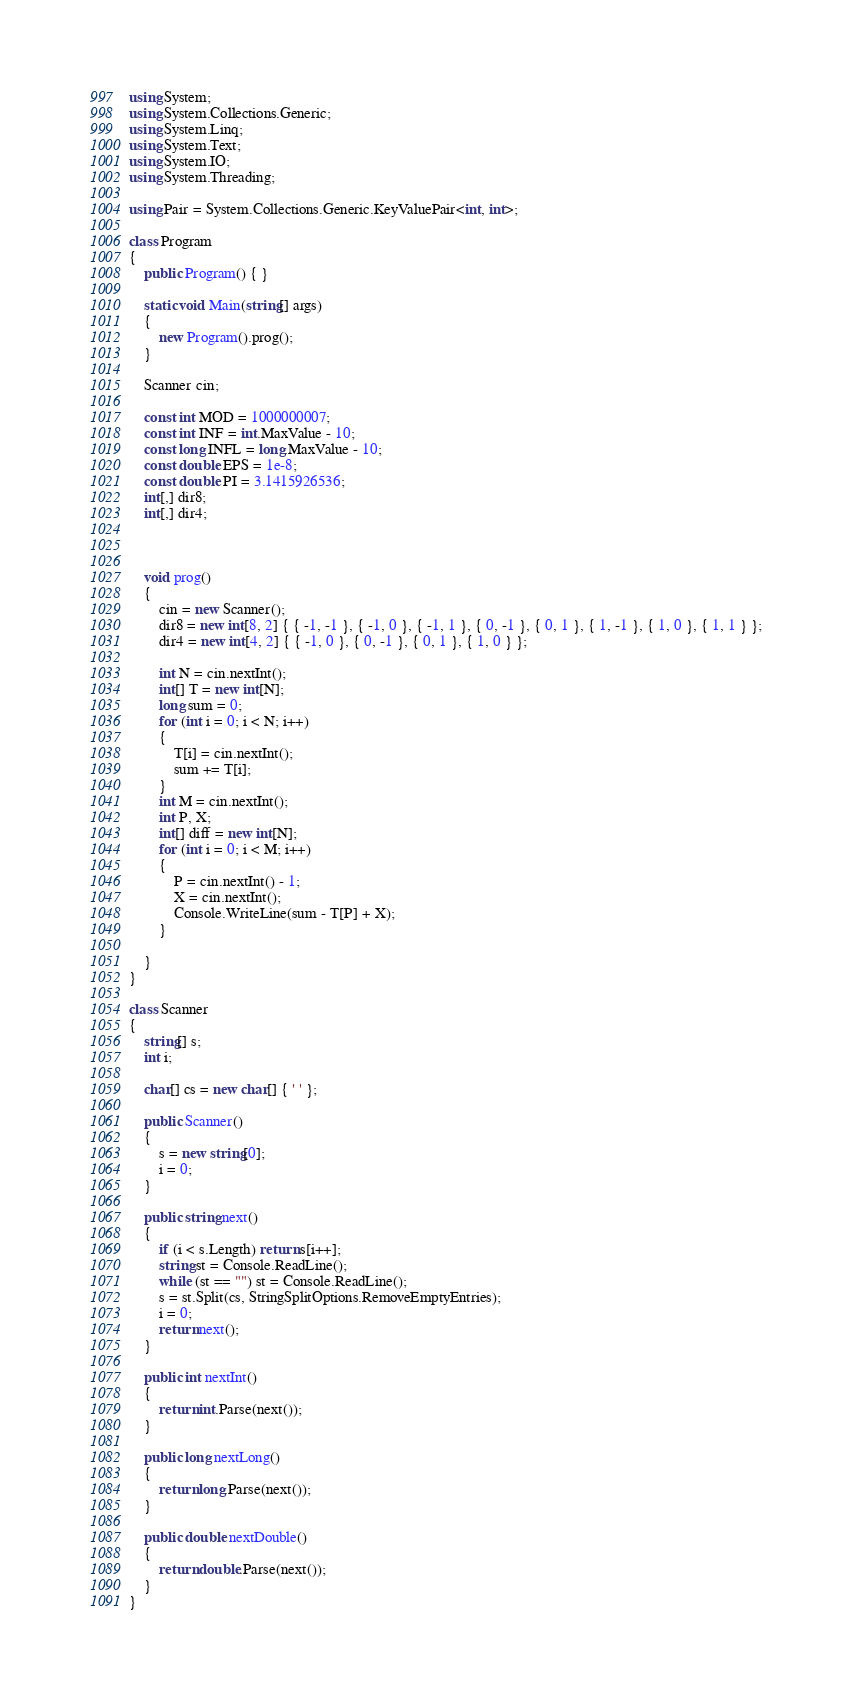Convert code to text. <code><loc_0><loc_0><loc_500><loc_500><_C#_>using System;
using System.Collections.Generic;
using System.Linq;
using System.Text;
using System.IO;
using System.Threading;

using Pair = System.Collections.Generic.KeyValuePair<int, int>;

class Program
{
	public Program() { }

	static void Main(string[] args)
	{
		new Program().prog();
	}

	Scanner cin;

	const int MOD = 1000000007;
	const int INF = int.MaxValue - 10;
	const long INFL = long.MaxValue - 10;
	const double EPS = 1e-8;
	const double PI = 3.1415926536;
	int[,] dir8;
	int[,] dir4;



	void prog()
	{
		cin = new Scanner();
		dir8 = new int[8, 2] { { -1, -1 }, { -1, 0 }, { -1, 1 }, { 0, -1 }, { 0, 1 }, { 1, -1 }, { 1, 0 }, { 1, 1 } };
		dir4 = new int[4, 2] { { -1, 0 }, { 0, -1 }, { 0, 1 }, { 1, 0 } };

		int N = cin.nextInt();
		int[] T = new int[N];
		long sum = 0;
		for (int i = 0; i < N; i++)
		{
			T[i] = cin.nextInt();
			sum += T[i];
		}
		int M = cin.nextInt();
		int P, X;
		int[] diff = new int[N];
		for (int i = 0; i < M; i++)
		{
			P = cin.nextInt() - 1;
			X = cin.nextInt();
			Console.WriteLine(sum - T[P] + X);
		}

	}
}

class Scanner
{
	string[] s;
	int i;

	char[] cs = new char[] { ' ' };

	public Scanner()
	{
		s = new string[0];
		i = 0;
	}

	public string next()
	{
		if (i < s.Length) return s[i++];
		string st = Console.ReadLine();
		while (st == "") st = Console.ReadLine();
		s = st.Split(cs, StringSplitOptions.RemoveEmptyEntries);
		i = 0;
		return next();
	}

	public int nextInt()
	{
		return int.Parse(next());
	}

	public long nextLong()
	{
		return long.Parse(next());
	}

	public double nextDouble()
	{
		return double.Parse(next());
	}
}</code> 